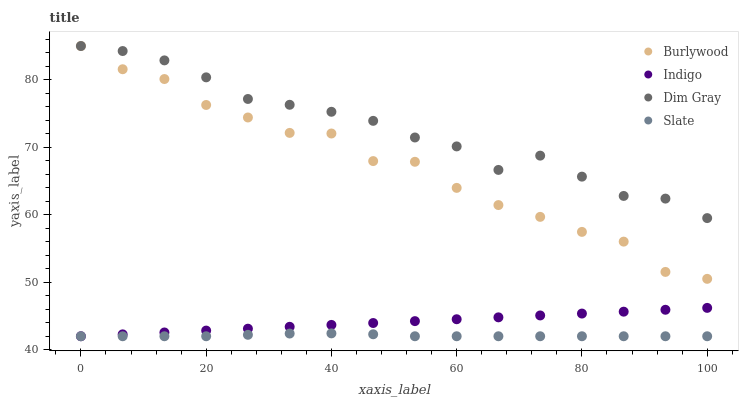Does Slate have the minimum area under the curve?
Answer yes or no. Yes. Does Dim Gray have the maximum area under the curve?
Answer yes or no. Yes. Does Dim Gray have the minimum area under the curve?
Answer yes or no. No. Does Slate have the maximum area under the curve?
Answer yes or no. No. Is Indigo the smoothest?
Answer yes or no. Yes. Is Burlywood the roughest?
Answer yes or no. Yes. Is Slate the smoothest?
Answer yes or no. No. Is Slate the roughest?
Answer yes or no. No. Does Slate have the lowest value?
Answer yes or no. Yes. Does Dim Gray have the lowest value?
Answer yes or no. No. Does Dim Gray have the highest value?
Answer yes or no. Yes. Does Slate have the highest value?
Answer yes or no. No. Is Indigo less than Dim Gray?
Answer yes or no. Yes. Is Dim Gray greater than Indigo?
Answer yes or no. Yes. Does Slate intersect Indigo?
Answer yes or no. Yes. Is Slate less than Indigo?
Answer yes or no. No. Is Slate greater than Indigo?
Answer yes or no. No. Does Indigo intersect Dim Gray?
Answer yes or no. No. 